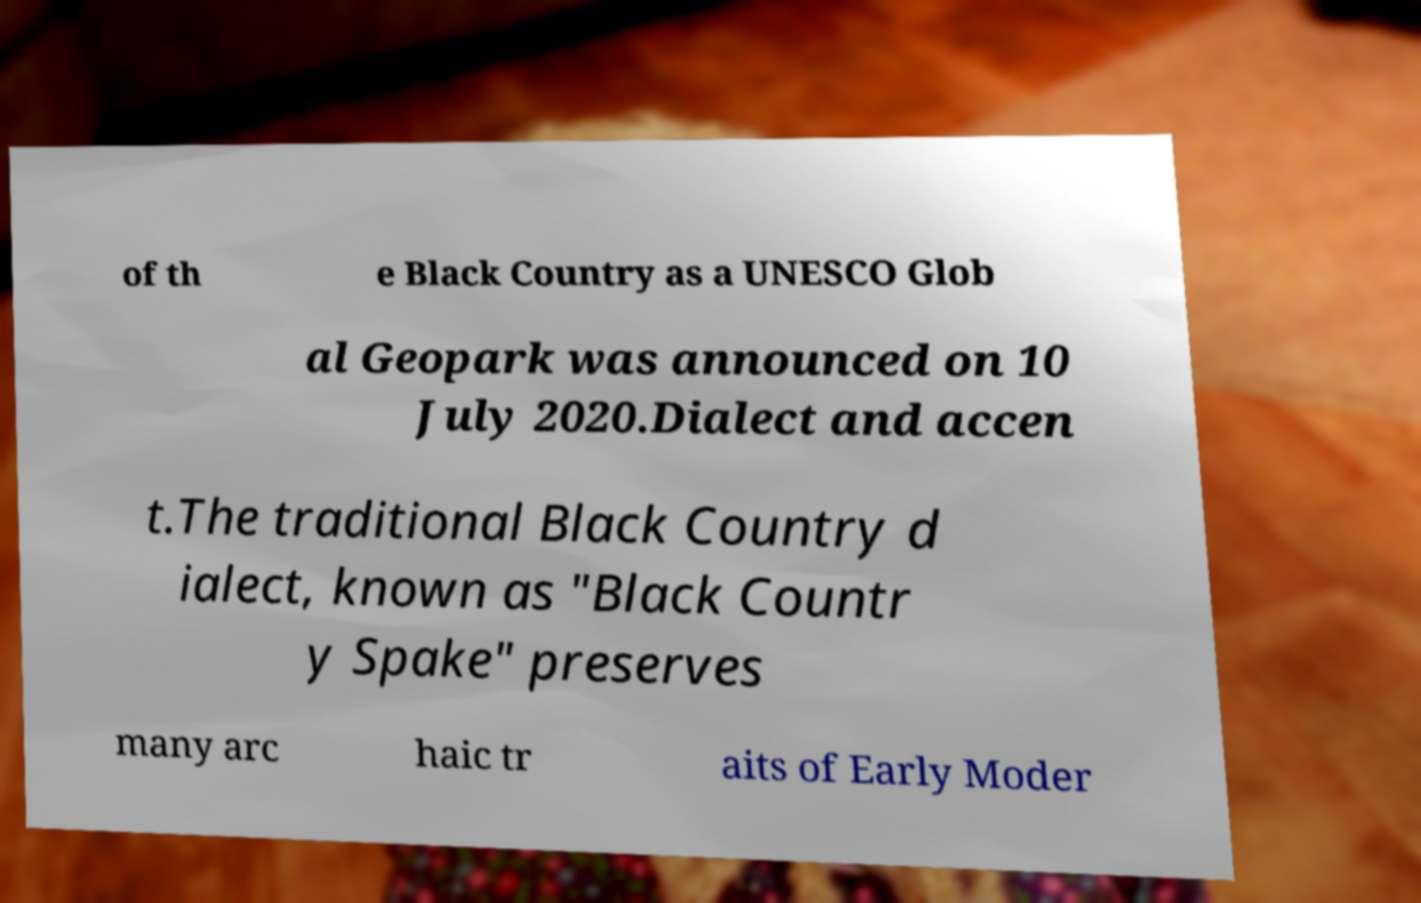I need the written content from this picture converted into text. Can you do that? of th e Black Country as a UNESCO Glob al Geopark was announced on 10 July 2020.Dialect and accen t.The traditional Black Country d ialect, known as "Black Countr y Spake" preserves many arc haic tr aits of Early Moder 